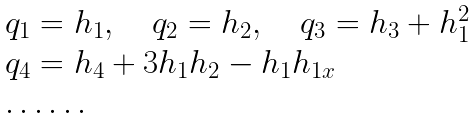<formula> <loc_0><loc_0><loc_500><loc_500>\begin{array} { l } q _ { 1 } = h _ { 1 } , \quad q _ { 2 } = h _ { 2 } , \quad q _ { 3 } = h _ { 3 } + h _ { 1 } ^ { 2 } \\ q _ { 4 } = h _ { 4 } + 3 h _ { 1 } h _ { 2 } - h _ { 1 } h _ { 1 x } \\ \dots \dots \end{array}</formula> 